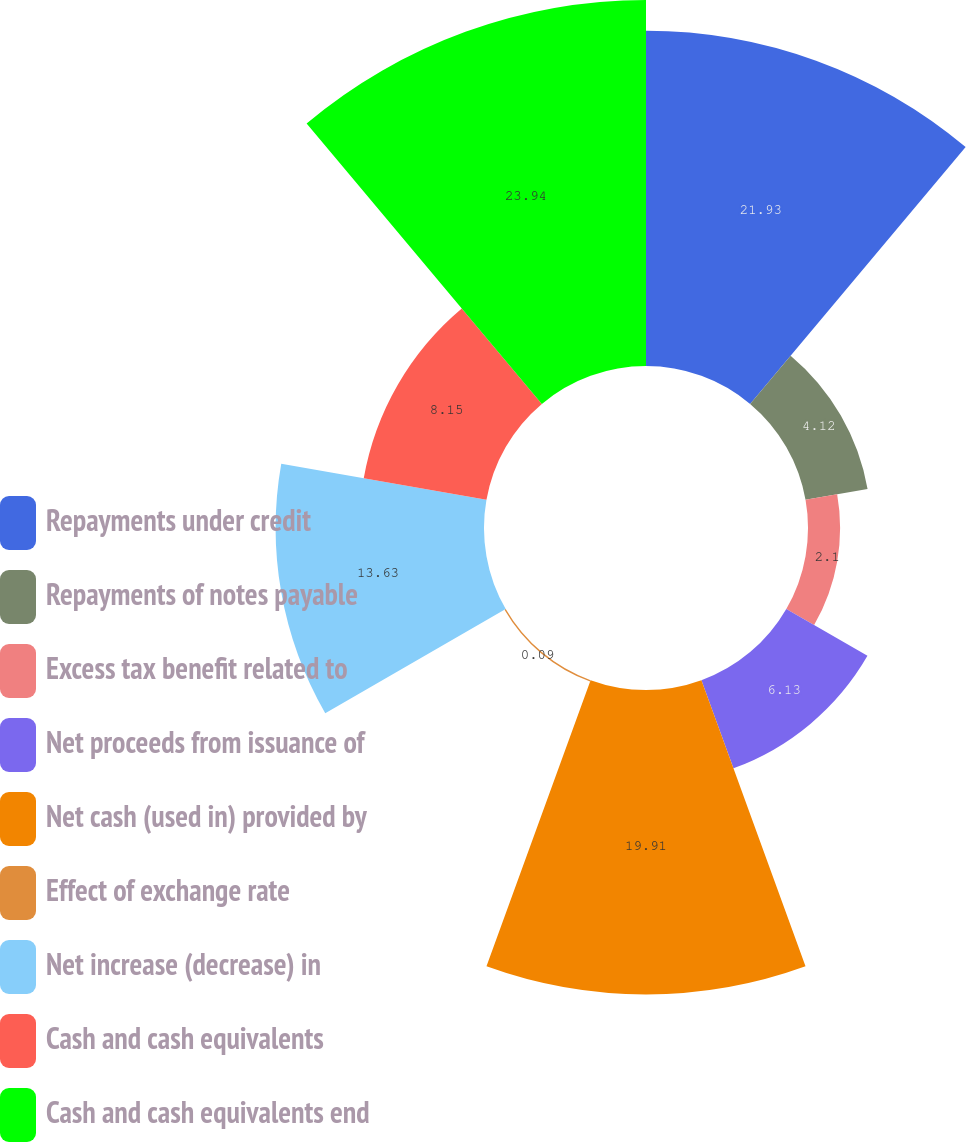<chart> <loc_0><loc_0><loc_500><loc_500><pie_chart><fcel>Repayments under credit<fcel>Repayments of notes payable<fcel>Excess tax benefit related to<fcel>Net proceeds from issuance of<fcel>Net cash (used in) provided by<fcel>Effect of exchange rate<fcel>Net increase (decrease) in<fcel>Cash and cash equivalents<fcel>Cash and cash equivalents end<nl><fcel>21.93%<fcel>4.12%<fcel>2.1%<fcel>6.13%<fcel>19.91%<fcel>0.09%<fcel>13.63%<fcel>8.15%<fcel>23.94%<nl></chart> 